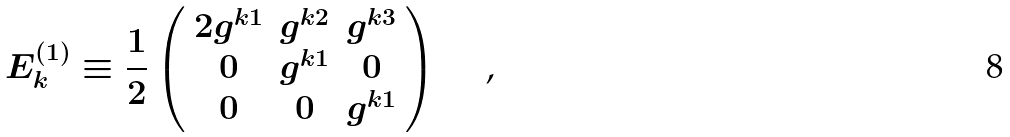<formula> <loc_0><loc_0><loc_500><loc_500>E _ { k } ^ { ( 1 ) } \equiv \frac { 1 } { 2 } \left ( \begin{array} { c c c } 2 g ^ { k 1 } & g ^ { k 2 } & g ^ { k 3 } \\ 0 & g ^ { k 1 } & 0 \\ 0 & 0 & g ^ { k 1 } \end{array} \right ) \text { \quad ,}</formula> 